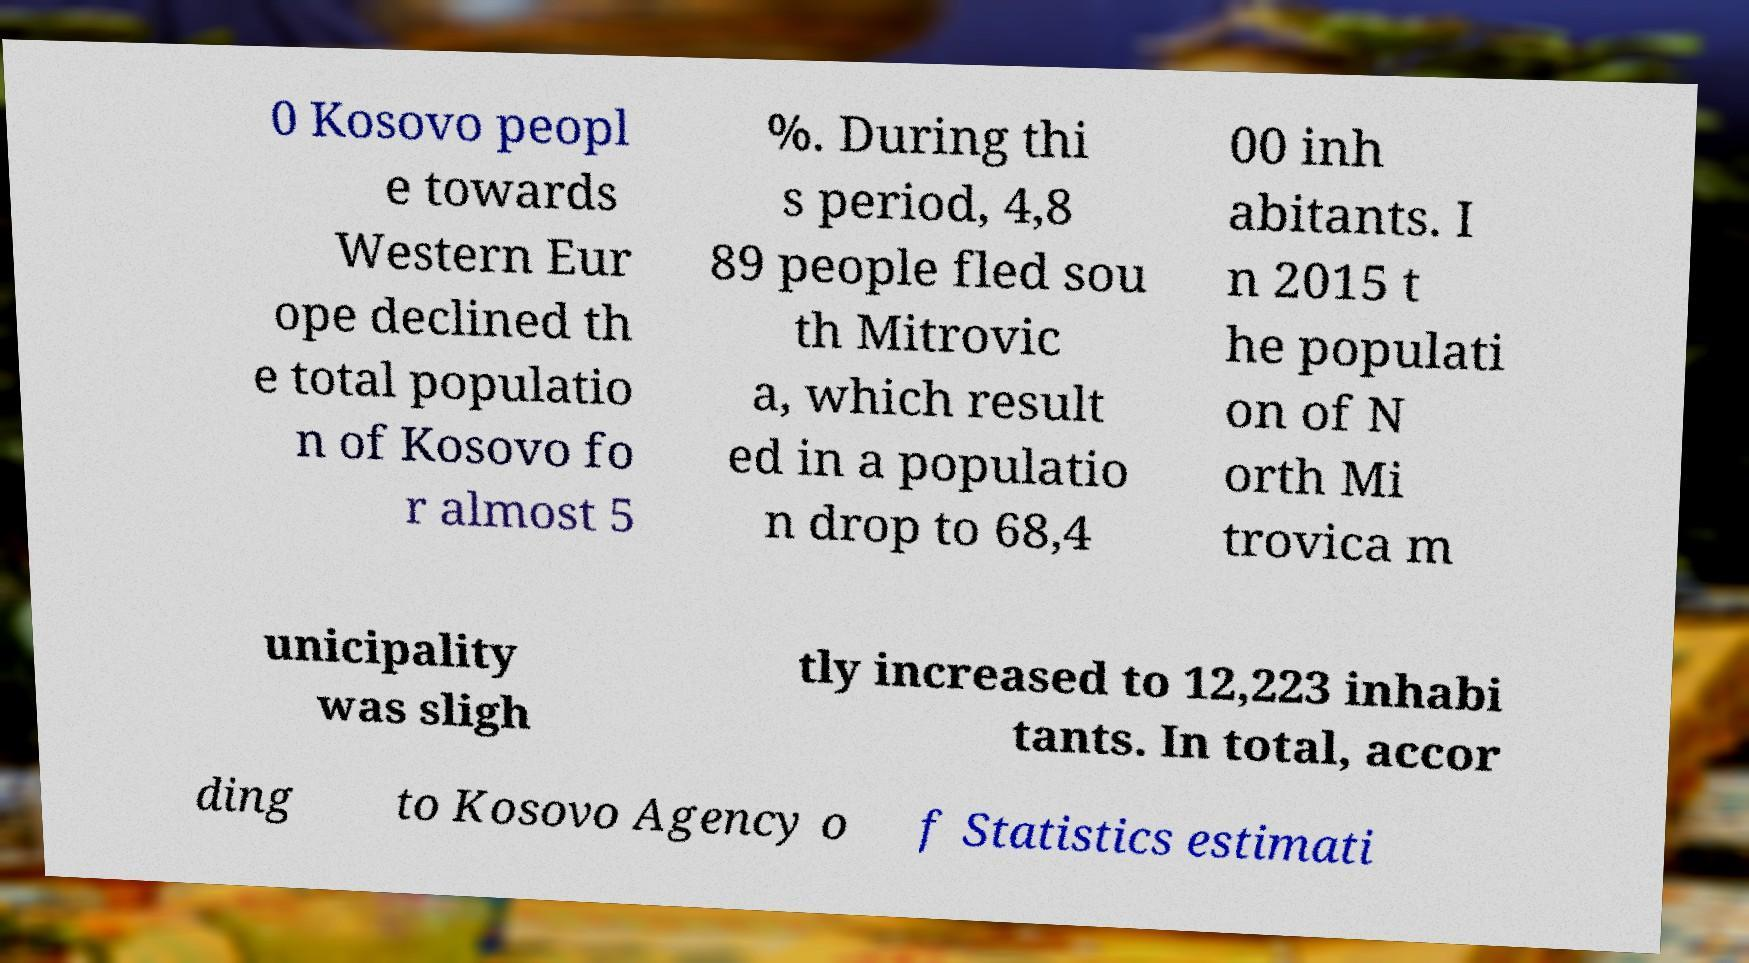Please read and relay the text visible in this image. What does it say? 0 Kosovo peopl e towards Western Eur ope declined th e total populatio n of Kosovo fo r almost 5 %. During thi s period, 4,8 89 people fled sou th Mitrovic a, which result ed in a populatio n drop to 68,4 00 inh abitants. I n 2015 t he populati on of N orth Mi trovica m unicipality was sligh tly increased to 12,223 inhabi tants. In total, accor ding to Kosovo Agency o f Statistics estimati 